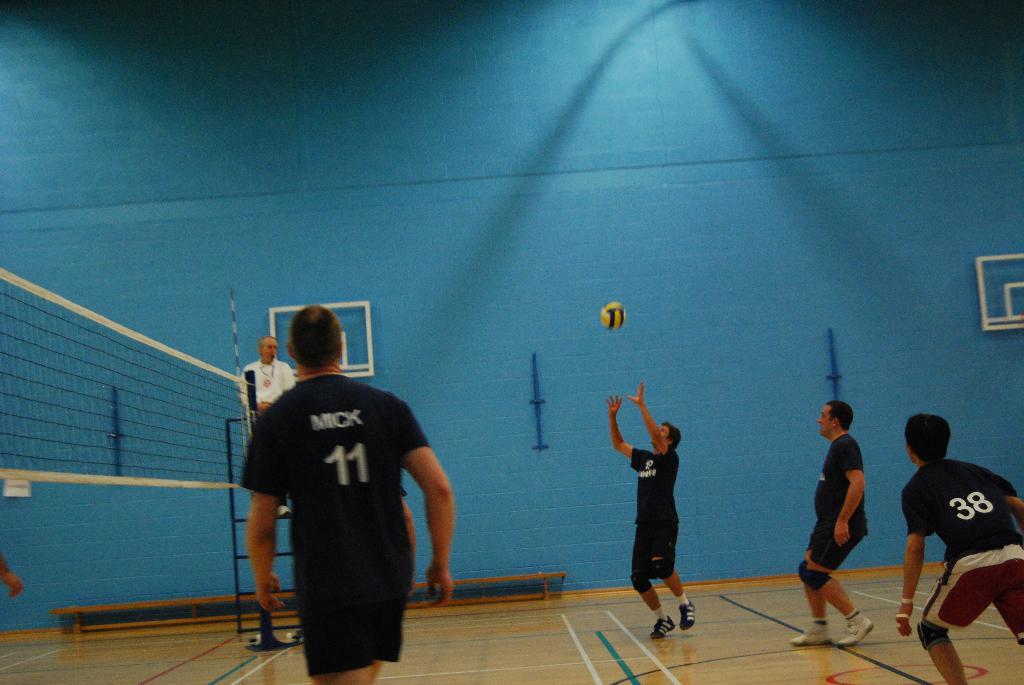What number is the guy in the red shorts?
Your answer should be compact. 38. What is the number of the plater on the left?
Offer a very short reply. 11. 